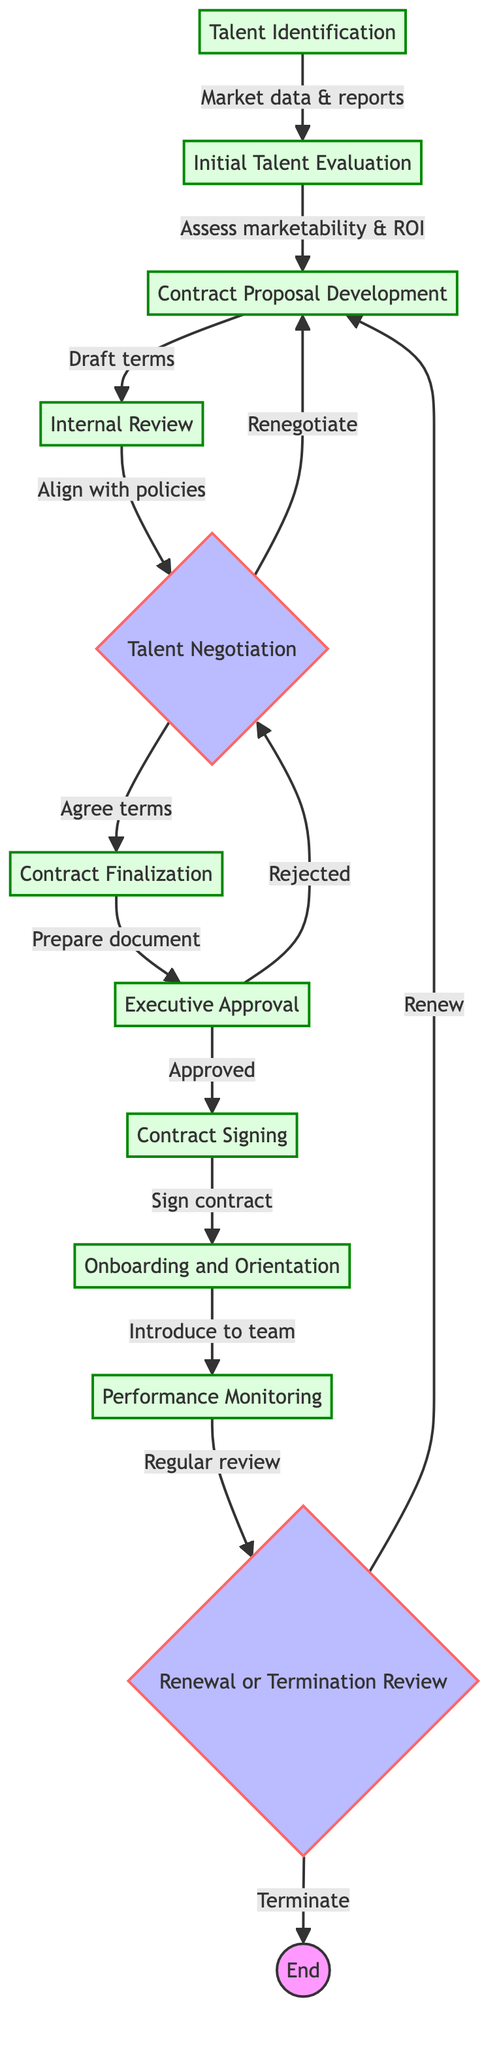What is the first step in the process? The first step in the process is Talent Identification, as indicated by the starting node in the flow chart.
Answer: Talent Identification How many steps are there before Executive Approval? There are five steps leading to Executive Approval, which are Talent Identification, Initial Talent Evaluation, Contract Proposal Development, Internal Review, and Talent Negotiation.
Answer: Five What happens if the Executive Approval is rejected? If the Executive Approval is rejected, the process flows back to the Talent Negotiation step to renegotiate terms.
Answer: Renegotiate What is the final outcome of the process if the contract is terminated? If the contract is terminated, the process ends as indicated by the End node, which represents the conclusion of the talent management process.
Answer: End Which step involves introducing talent to the production team? The step that involves introducing talent to the production team is Onboarding and Orientation. This is shown in the flow between Contract Signing and Performance Monitoring.
Answer: Onboarding and Orientation In which step is performance regularly reviewed? Performance is regularly reviewed in the Performance Monitoring step, which follows the Onboarding and Orientation step in the diagram.
Answer: Performance Monitoring How does the flow proceed after Contract Finalization? After Contract Finalization, the flow proceeds to Executive Approval, indicating that the final contract document is reviewed and approval sought from senior executives.
Answer: Executive Approval What is the role of the Internal Review step? The Internal Review step serves to ensure that the contract terms align with company policies and budget through a review meeting with relevant departments.
Answer: Align with policies What is the action taken if the Talent Negotiation is successful? If the Talent Negotiation is successful, the next action is Contract Finalization, where the final contract document is prepared incorporating all agreed terms.
Answer: Contract Finalization 